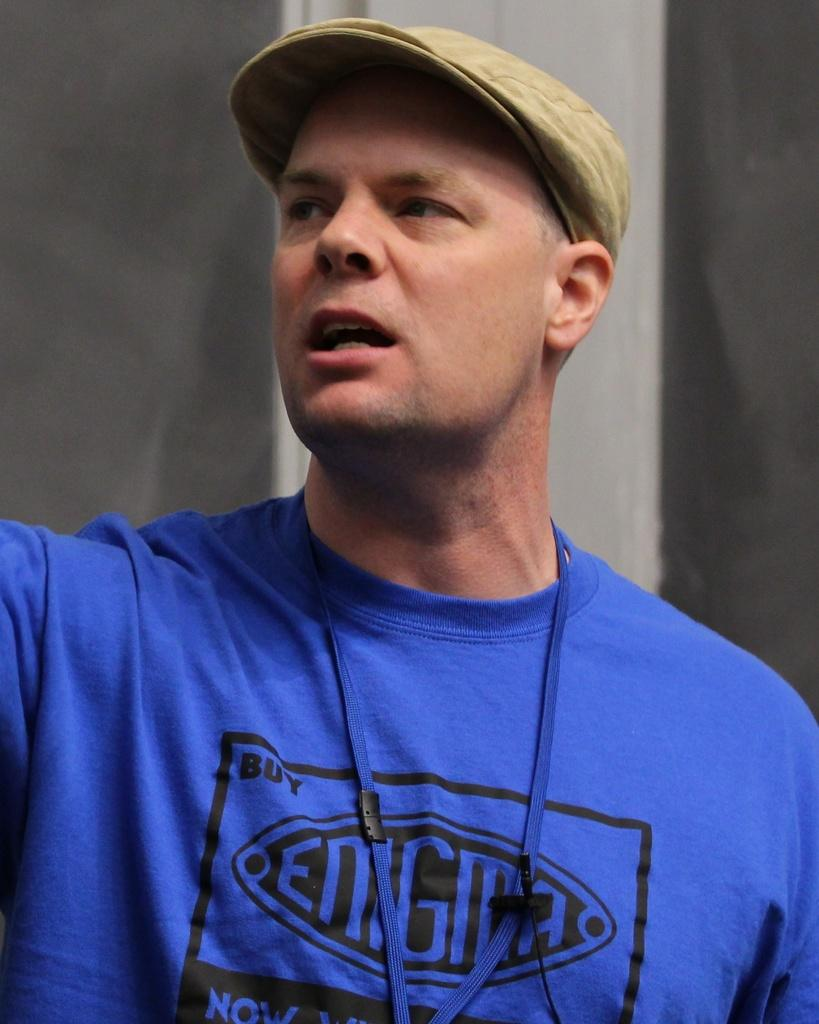<image>
Write a terse but informative summary of the picture. A man with a blue shirt that says Enigma, is wearing a brown hat. 